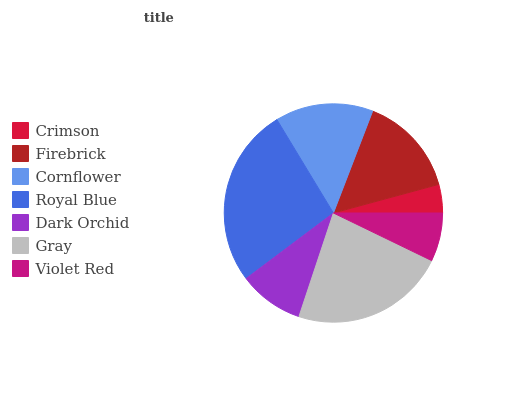Is Crimson the minimum?
Answer yes or no. Yes. Is Royal Blue the maximum?
Answer yes or no. Yes. Is Firebrick the minimum?
Answer yes or no. No. Is Firebrick the maximum?
Answer yes or no. No. Is Firebrick greater than Crimson?
Answer yes or no. Yes. Is Crimson less than Firebrick?
Answer yes or no. Yes. Is Crimson greater than Firebrick?
Answer yes or no. No. Is Firebrick less than Crimson?
Answer yes or no. No. Is Cornflower the high median?
Answer yes or no. Yes. Is Cornflower the low median?
Answer yes or no. Yes. Is Gray the high median?
Answer yes or no. No. Is Firebrick the low median?
Answer yes or no. No. 